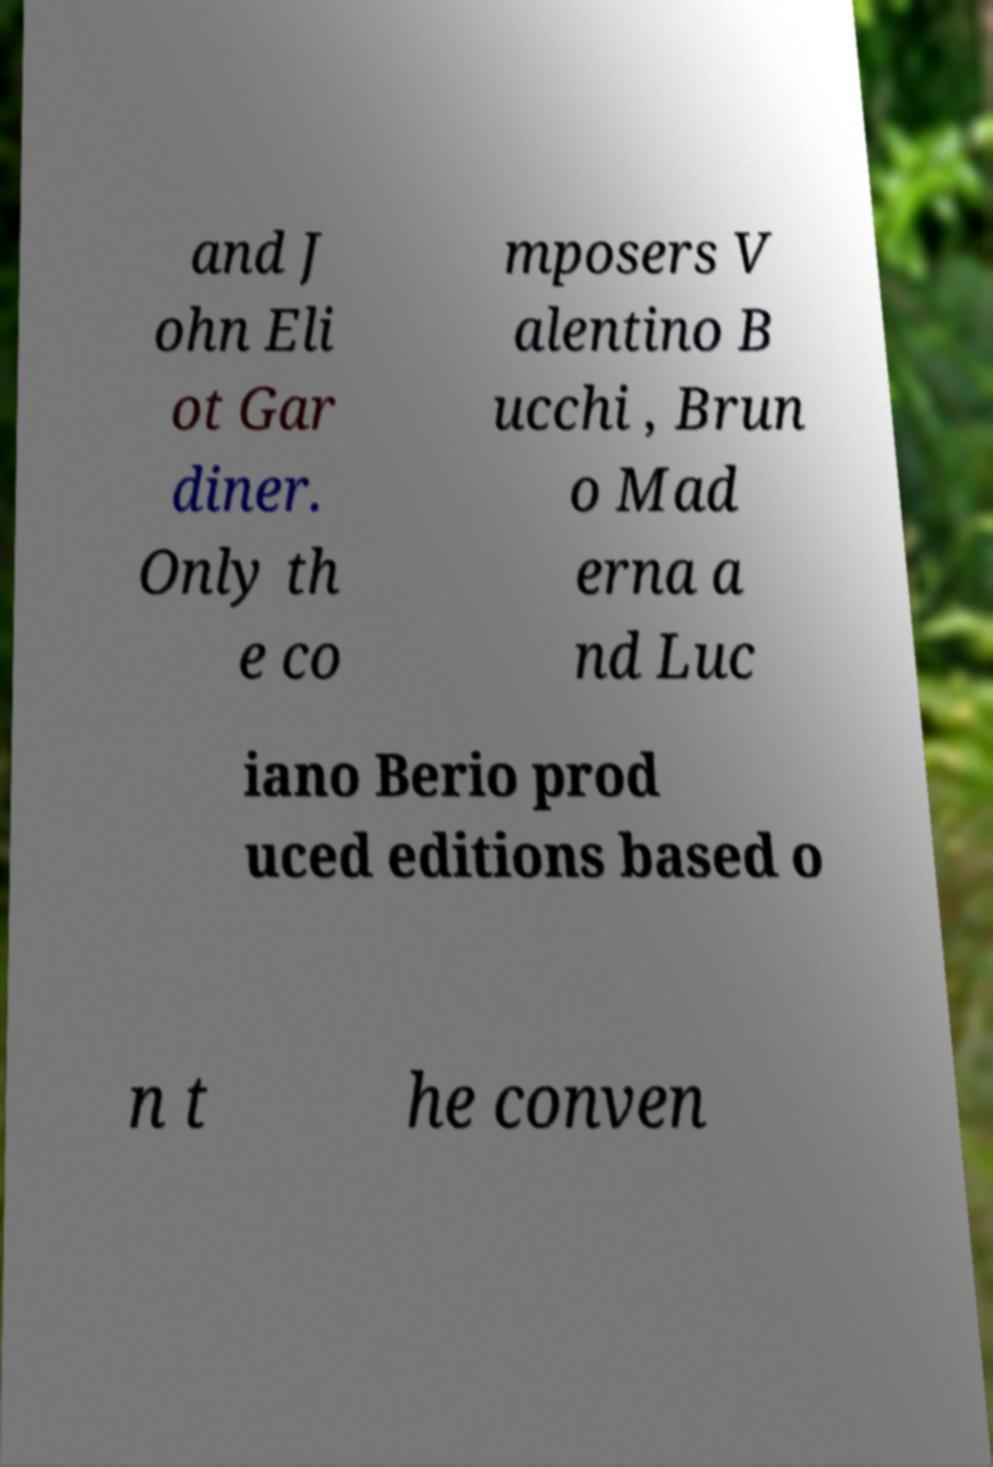Can you read and provide the text displayed in the image?This photo seems to have some interesting text. Can you extract and type it out for me? and J ohn Eli ot Gar diner. Only th e co mposers V alentino B ucchi , Brun o Mad erna a nd Luc iano Berio prod uced editions based o n t he conven 